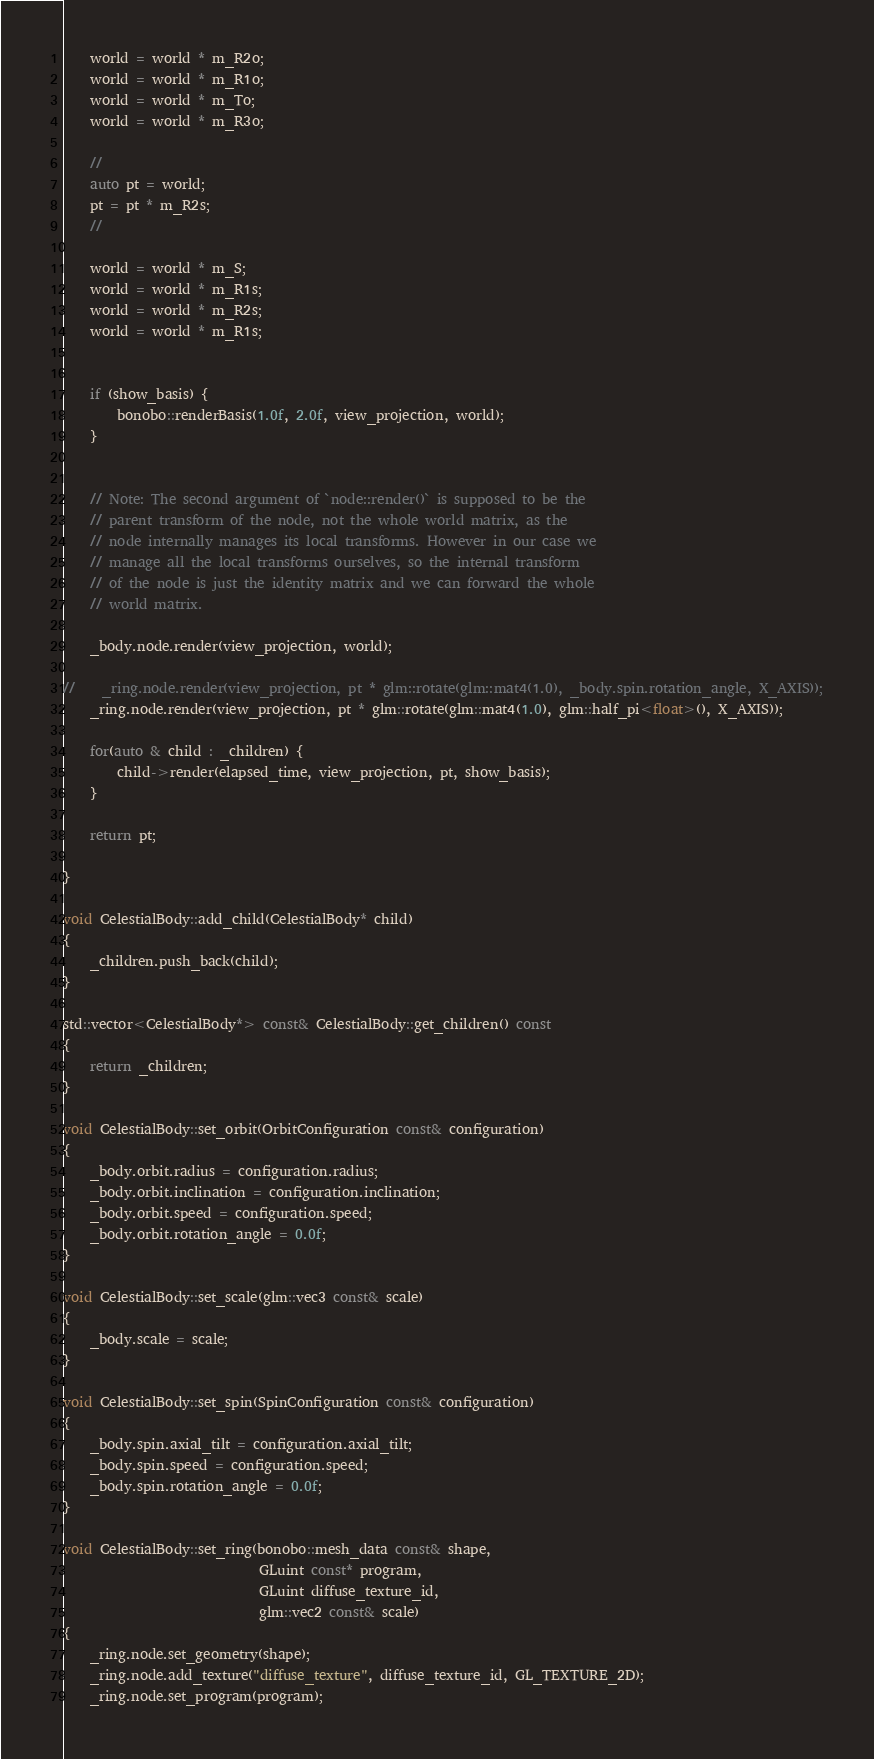<code> <loc_0><loc_0><loc_500><loc_500><_C++_>    world = world * m_R2o;
    world = world * m_R1o;
    world = world * m_To;
    world = world * m_R3o;

    //
    auto pt = world;
    pt = pt * m_R2s;
    //

    world = world * m_S;
    world = world * m_R1s;
    world = world * m_R2s;
    world = world * m_R1s;


	if (show_basis) {
        bonobo::renderBasis(1.0f, 2.0f, view_projection, world);
    }


	// Note: The second argument of `node::render()` is supposed to be the
	// parent transform of the node, not the whole world matrix, as the
	// node internally manages its local transforms. However in our case we
	// manage all the local transforms ourselves, so the internal transform
	// of the node is just the identity matrix and we can forward the whole
	// world matrix.

	_body.node.render(view_projection, world);

//    _ring.node.render(view_projection, pt * glm::rotate(glm::mat4(1.0), _body.spin.rotation_angle, X_AXIS));
    _ring.node.render(view_projection, pt * glm::rotate(glm::mat4(1.0), glm::half_pi<float>(), X_AXIS));

    for(auto & child : _children) {
        child->render(elapsed_time, view_projection, pt, show_basis);
    }

    return pt;

}

void CelestialBody::add_child(CelestialBody* child)
{
	_children.push_back(child);
}

std::vector<CelestialBody*> const& CelestialBody::get_children() const
{
	return _children;
}

void CelestialBody::set_orbit(OrbitConfiguration const& configuration)
{
	_body.orbit.radius = configuration.radius;
	_body.orbit.inclination = configuration.inclination;
	_body.orbit.speed = configuration.speed;
	_body.orbit.rotation_angle = 0.0f;
}

void CelestialBody::set_scale(glm::vec3 const& scale)
{
	_body.scale = scale;
}

void CelestialBody::set_spin(SpinConfiguration const& configuration)
{
	_body.spin.axial_tilt = configuration.axial_tilt;
	_body.spin.speed = configuration.speed;
	_body.spin.rotation_angle = 0.0f;
}

void CelestialBody::set_ring(bonobo::mesh_data const& shape,
                             GLuint const* program,
                             GLuint diffuse_texture_id,
                             glm::vec2 const& scale)
{
	_ring.node.set_geometry(shape);
	_ring.node.add_texture("diffuse_texture", diffuse_texture_id, GL_TEXTURE_2D);
	_ring.node.set_program(program);
</code> 